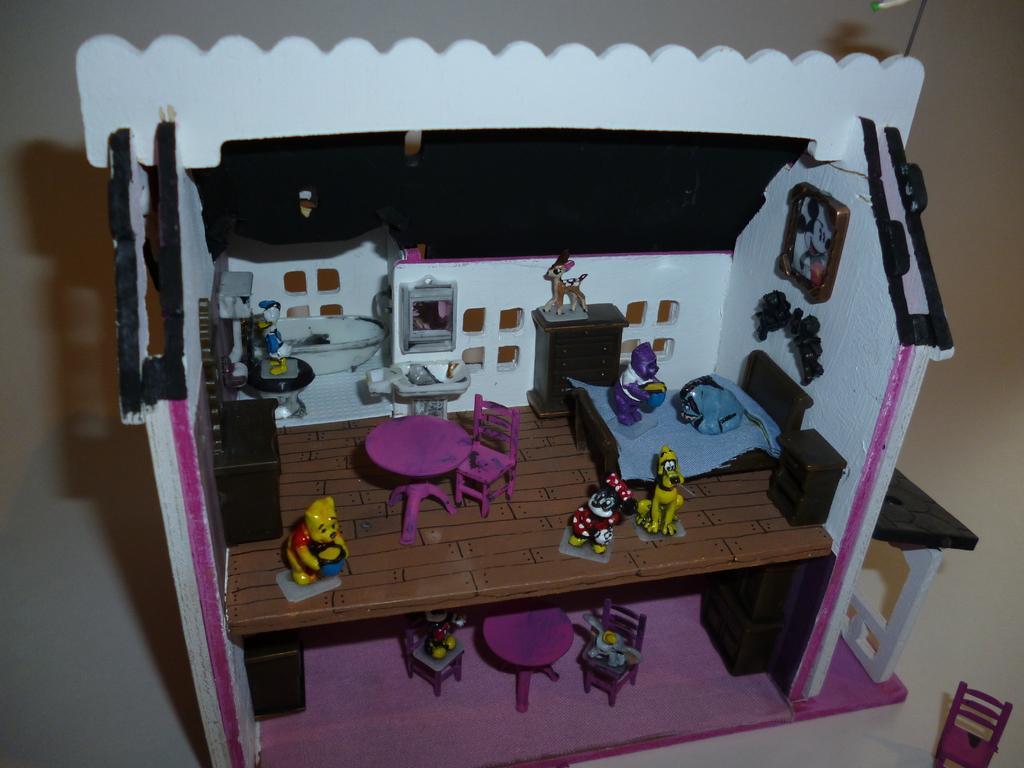Could you give a brief overview of what you see in this image? In this picture there is a house with some toys, a bed, chair and table. 